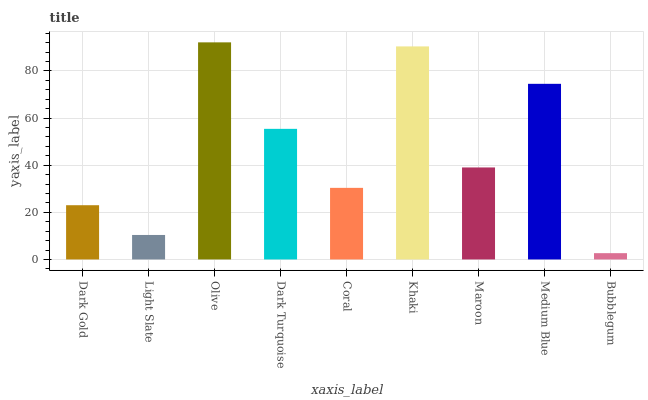Is Olive the maximum?
Answer yes or no. Yes. Is Light Slate the minimum?
Answer yes or no. No. Is Light Slate the maximum?
Answer yes or no. No. Is Dark Gold greater than Light Slate?
Answer yes or no. Yes. Is Light Slate less than Dark Gold?
Answer yes or no. Yes. Is Light Slate greater than Dark Gold?
Answer yes or no. No. Is Dark Gold less than Light Slate?
Answer yes or no. No. Is Maroon the high median?
Answer yes or no. Yes. Is Maroon the low median?
Answer yes or no. Yes. Is Olive the high median?
Answer yes or no. No. Is Dark Gold the low median?
Answer yes or no. No. 